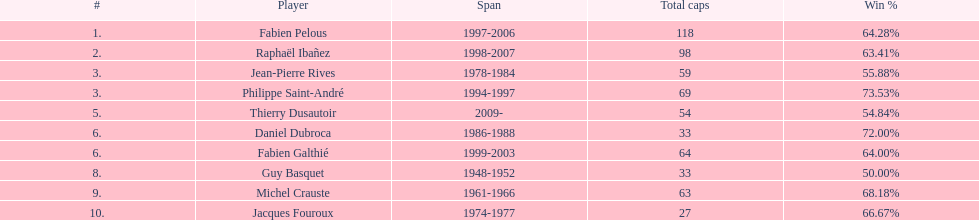How many captains played 11 capped matches? 5. 